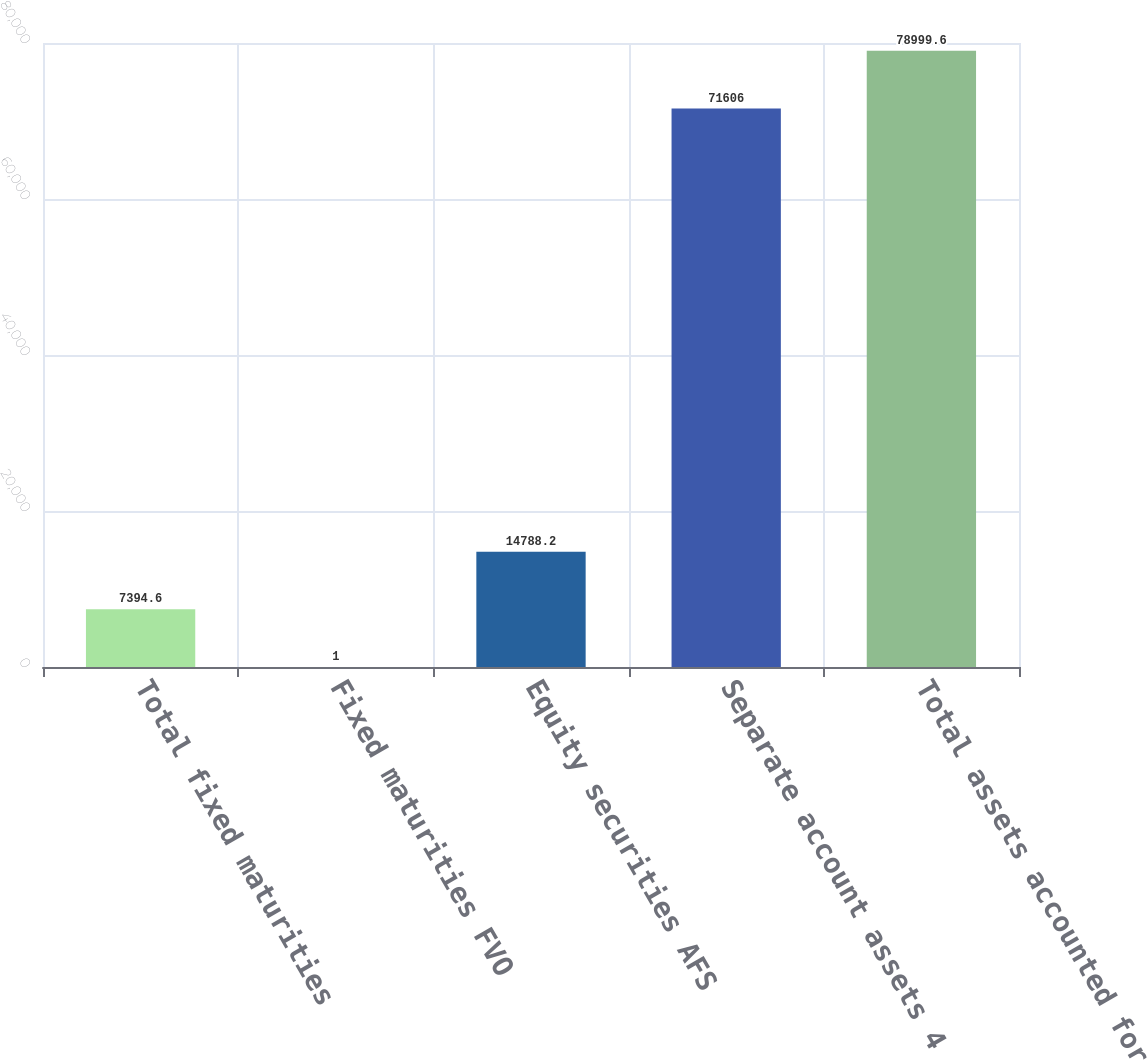Convert chart to OTSL. <chart><loc_0><loc_0><loc_500><loc_500><bar_chart><fcel>Total fixed maturities<fcel>Fixed maturities FVO<fcel>Equity securities AFS<fcel>Separate account assets 4<fcel>Total assets accounted for at<nl><fcel>7394.6<fcel>1<fcel>14788.2<fcel>71606<fcel>78999.6<nl></chart> 